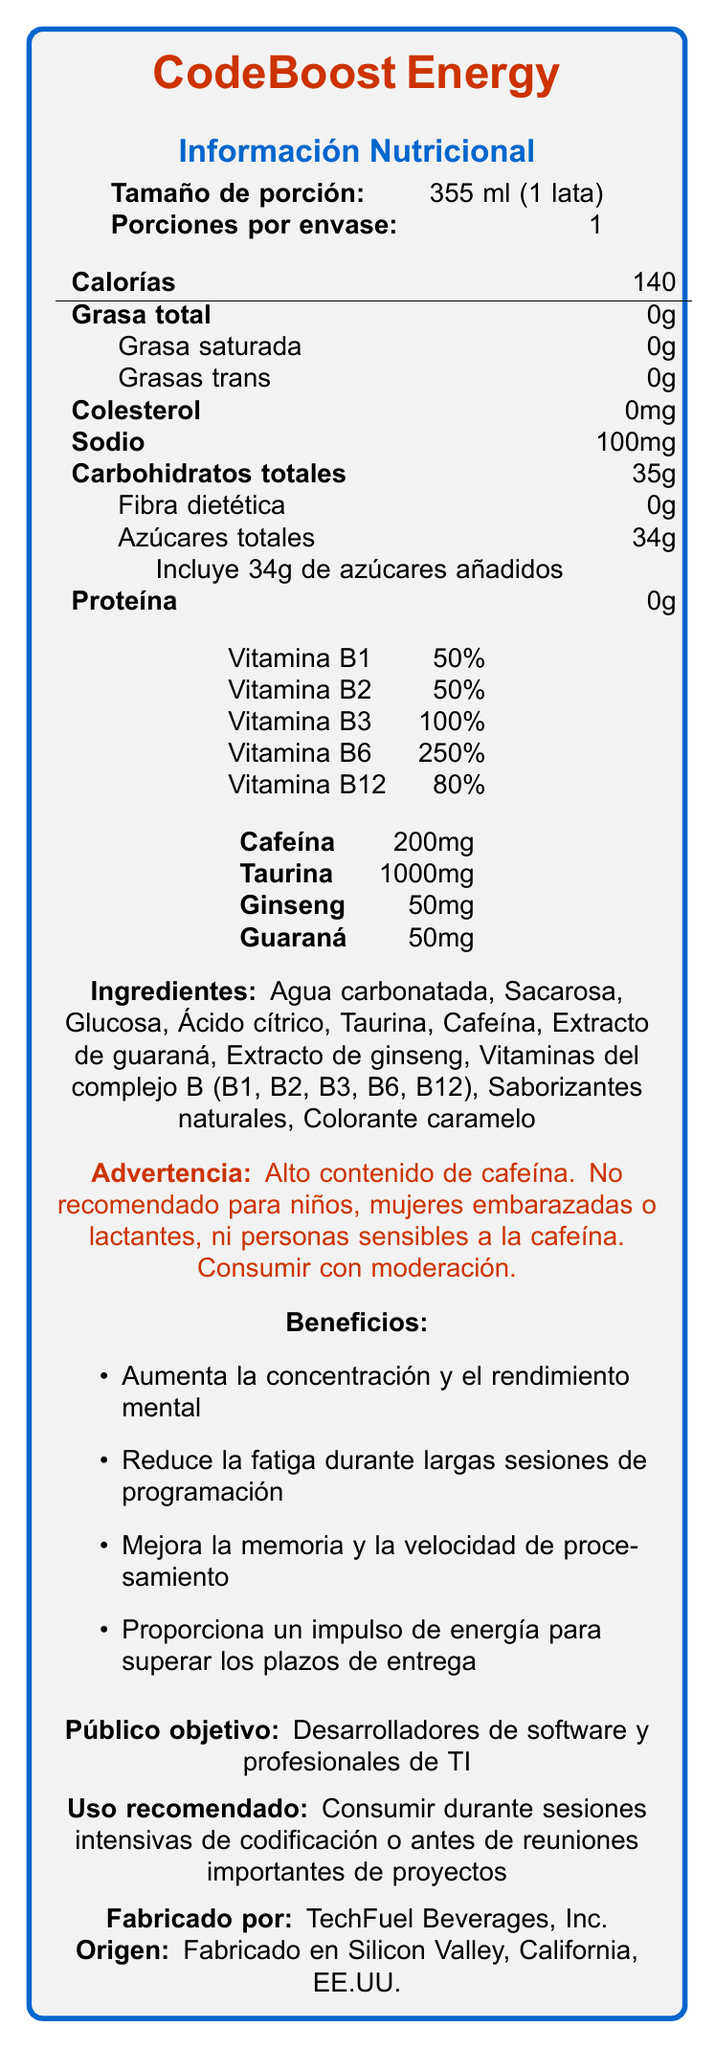what is the serving size of CodeBoost Energy? The serving size is clearly listed as "355 ml (1 lata)" in the document.
Answer: 355 ml (1 lata) how many calories are in one container of CodeBoost Energy? The document states that there are 140 calories per serving, and there is 1 serving per container.
Answer: 140 What is the total carbohydrate content in one container? The document indicates "Carbohidratos totales: 35g" for one container.
Answer: 35g Which ingredient in CodeBoost Energy provides caffeine? Caffeine is mentioned as a separate ingredient, while "Extracto de guaraná" contributes additional caffeine.
Answer: Extracto de guaraná What is the percentage of the Daily Value for Vitamin B6 in CodeBoost Energy? The document lists "Vitamina B6 250%" in the nutritional information.
Answer: 250% Who is the manufacturer of CodeBoost Energy? The document states "Fabricado por: TechFuel Beverages, Inc."
Answer: TechFuel Beverages, Inc. How many milligrams of taurine are in one container of CodeBoost Energy? The document specifies "Taurina 1000mg" in the nutritional information.
Answer: 1000mg What are the benefits of consuming CodeBoost Energy? A. Reduces fatigue B. Increases mental performance C. Improves processing speed D. All of the above The document lists several benefits: increases concentration and mental performance, reduces fatigue, improves memory and processing speed, and provides an energy boost.
Answer: D What is the main purpose of CodeBoost Energy? A. General fitness B. High caffeine content C. For software developers D. For sports athletes The document targets "Desarrolladores de software y profesionales de TI" as the main audience.
Answer: C Does CodeBoost Energy contain any protein? The nutritional information shows "Proteína 0g," indicating there is no protein content.
Answer: No Is the product recommended for children? Yes/No The warning section states that the product is not recommended for children.
Answer: No Summarize the main features and audience of CodeBoost Energy. The document provides detailed nutritional information, ingredients, and highlights the target audience and intended benefits, mentioning enhanced mental performance and reduced fatigue for software developers.
Answer: CodeBoost Energy is a high-caffeine energy drink specifically formulated for software developers and IT professionals. It contains significant amounts of B vitamins, caffeine, taurine, ginseng, and guarana. The drink aims to enhance concentration, mental performance, and reduce fatigue during intensive coding sessions. What is the exact percentage of daily value for Vitamin C provided by CodeBoost Energy? The document does not mention Vitamin C in the provided nutritional information; therefore, the percentage of daily value cannot be determined.
Answer: Not enough information What is the main carbohydrate source in CodeBoost Energy? The ingredients list "Sacarosa" and "Glucosa," which are main sources of carbohydrates in the drink.
Answer: Sacarosa and Glucosa 